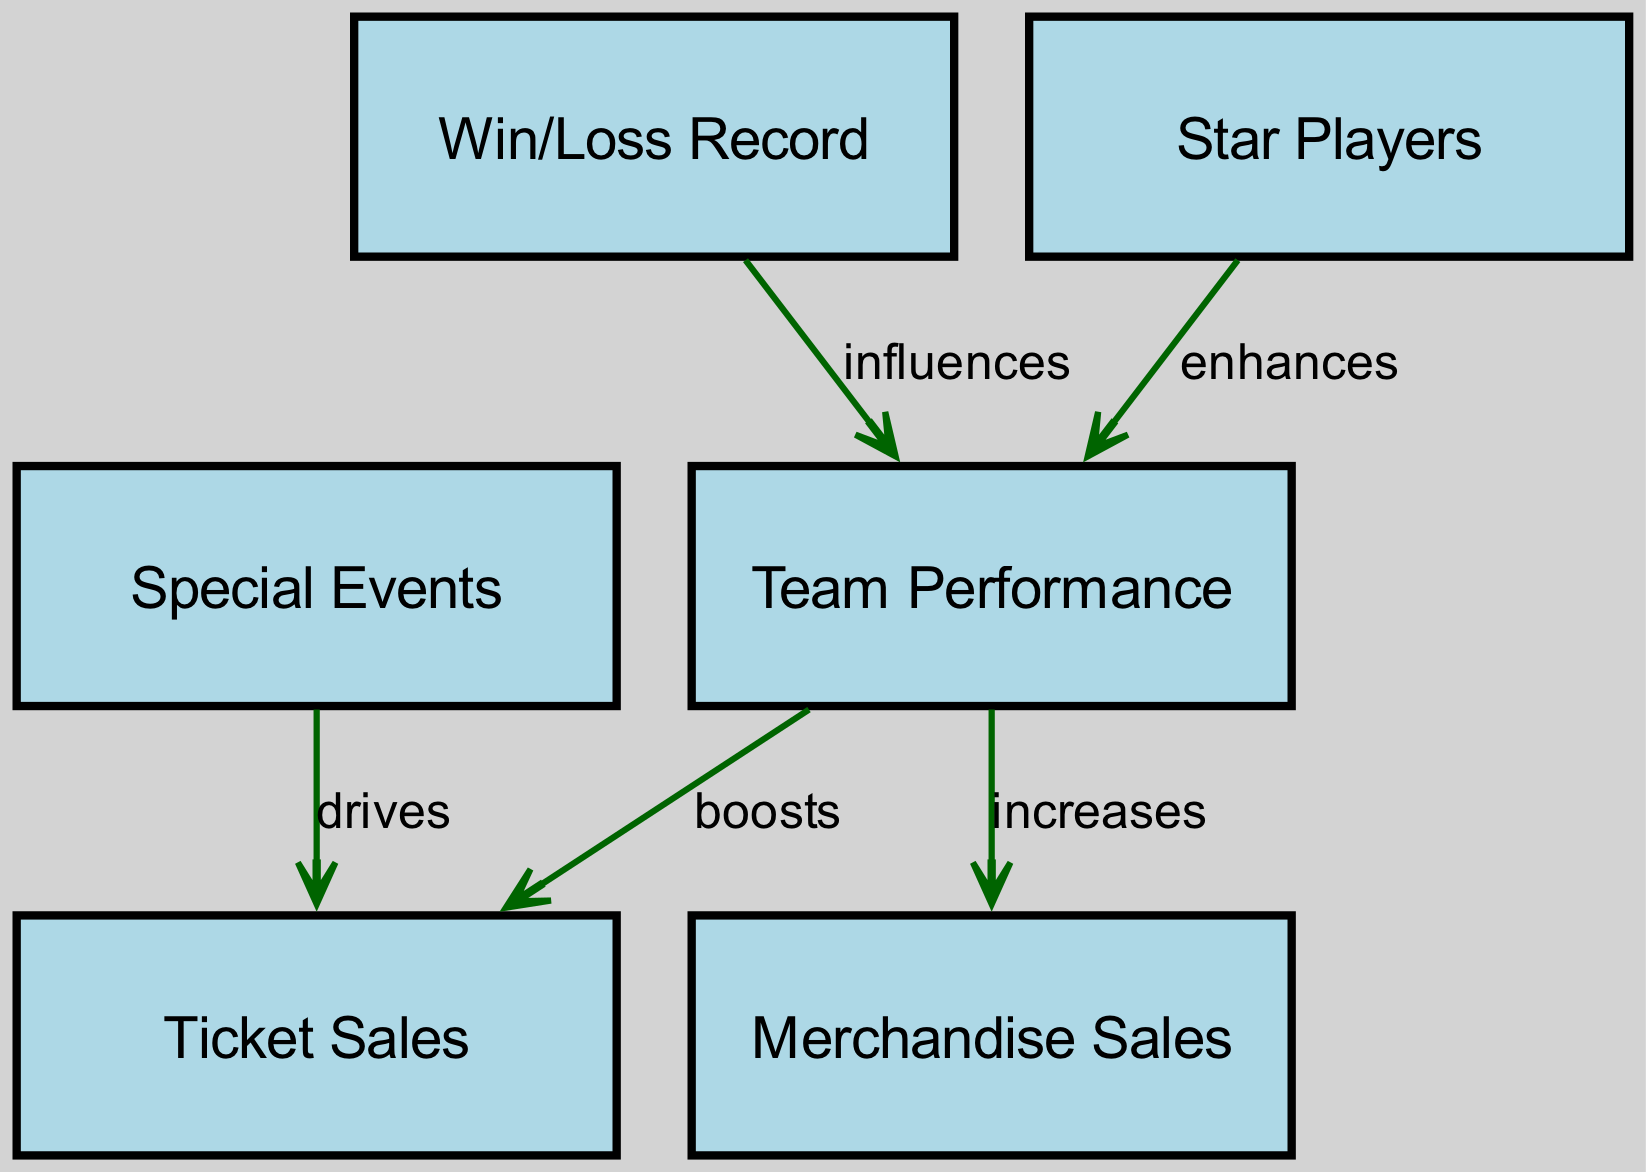What is the relationship between team performance and ticket sales? The diagram indicates that team performance "boosts" ticket sales, suggesting a positive impact where better team performance likely results in increased ticket sales.
Answer: boosts How many nodes are present in the diagram? The diagram includes six distinct nodes: team performance, ticket sales, merchandise sales, win/loss record, star players, and special events, leading to a total of six nodes.
Answer: 6 What influences team performance? The diagram shows that both the win/loss record and star players "influence" team performance, highlighting important factors that affect how well a team performs.
Answer: win/loss record, star players How does merchandise sales relate to team performance? The diagram states that merchandise sales are "increased" by team performance, indicating that more successful teams tend to sell more merchandise.
Answer: increases What drives ticket sales according to the diagram? According to the diagram, special events "drive" ticket sales, indicating that such events can significantly enhance the number of tickets sold.
Answer: drives If the win/loss record improves, what happens to team performance? As indicated in the diagram, an improved win/loss record "influences" team performance positively, suggesting that better performance in games leads to better overall team performance.
Answer: influences How many edges are represented in the diagram? Upon reviewing the diagram, there are five edges connecting the nodes, which represent the relationships between different factors influencing team performance and sales.
Answer: 5 What enhances team performance? The diagram specifies that star players "enhance" team performance, indicating that the presence of notable players significantly contributes to a team’s success.
Answer: enhances How many distinct relationships are shown between the nodes? The diagram features five distinct relationships (edges) between nodes, highlighting the connections among various factors such as team performance, ticket sales, and special events.
Answer: 5 